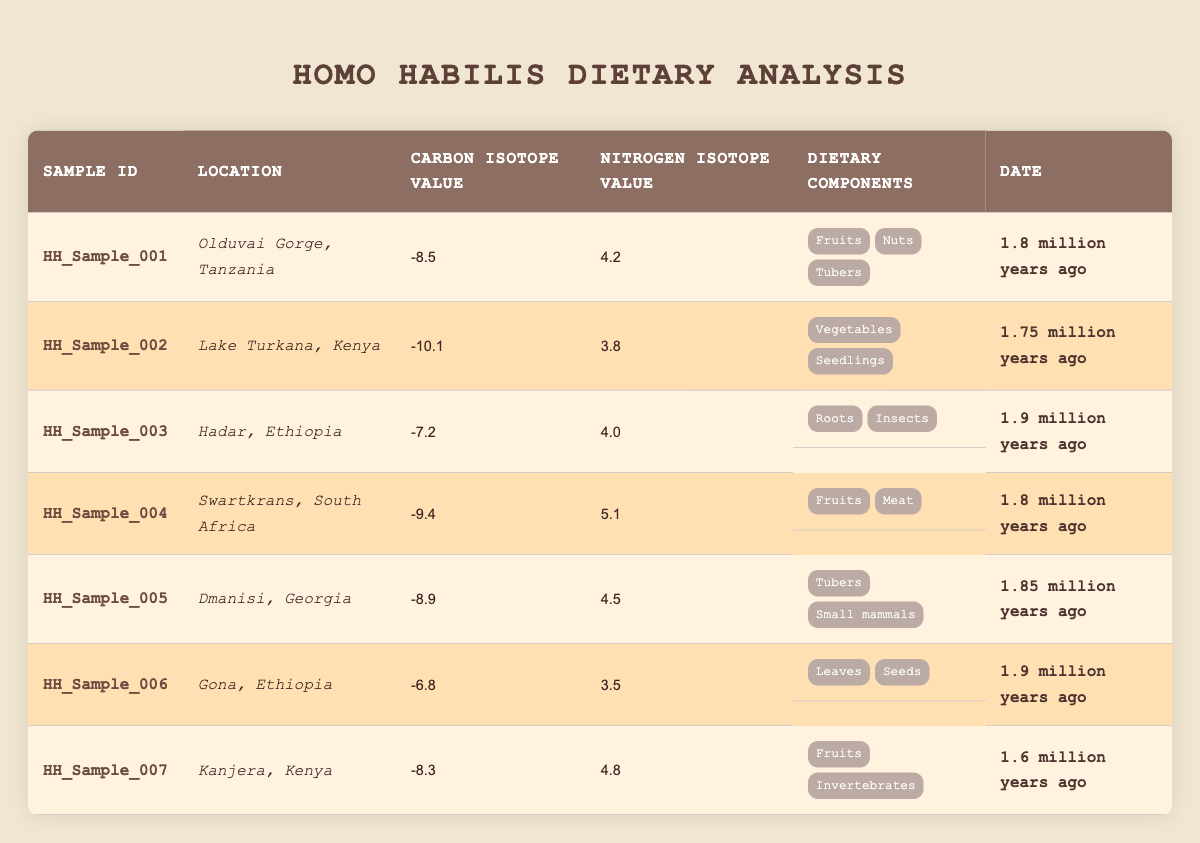What is the Carbon Isotope Value for the sample from Olduvai Gorge? The table lists the Carbon Isotope Value for the sample from Olduvai Gorge (Sample ID HH_Sample_001) as -8.5.
Answer: -8.5 Which sample has the highest Nitrogen Isotope Value? Upon examining the Nitrogen Isotope Values, Swartkrans (Sample ID HH_Sample_004) has the highest value of 5.1.
Answer: HH_Sample_004 How many dietary components are listed for the sample from Hadar? The table shows that the dietary components for the Hadar sample (Sample ID HH_Sample_003) include Roots and Insects, which totals to 2 components.
Answer: 2 Is there a sample that includes both fruits and meat in its dietary components? Yes, the Swartkrans sample (Sample ID HH_Sample_004) includes both fruits and meat in its dietary components.
Answer: Yes What is the difference between the highest and lowest Carbon Isotope Values? Checking the values, the highest Carbon Isotope Value is -6.8 (Sample HH_Sample_006) and the lowest is -10.1 (Sample HH_Sample_002). The difference is calculated as -6.8 - (-10.1) = 3.3.
Answer: 3.3 Which site has dietary components that include nuts? The site that includes dietary components of nuts is Olduvai Gorge (Sample ID HH_Sample_001).
Answer: Olduvai Gorge What is the average of the Nitrogen Isotope Values from all samples? The Nitrogen Isotope Values are 4.2, 3.8, 4.0, 5.1, 4.5, 3.5, and 4.8. Summing these values gives 30.9, and there are 7 samples. The average is calculated as 30.9 / 7 = 4.4142857, approximately 4.41.
Answer: 4.41 Which location had the sample dated at 1.9 million years ago with the highest Carbon Isotope Value? The samples dated at 1.9 million years ago are from Hadar (Carbon Isotope -7.2) and Gona (Carbon Isotope -6.8). Gona has the highest value at -6.8.
Answer: Gona Is it true that the maximum average dietary diversity is represented in the sample from Lake Turkana? Analyzing the dietary components, Lake Turkana has 2 components (Vegetables and Seedlings), while the sample from Swartkrans with 2 components (Fruits and Meat) yields slightly higher diversity. Thus, Lake Turkana does not represent maximum diversity.
Answer: No Which samples were collected from Kenya? The samples from Kenya are HH_Sample_002 (Lake Turkana) and HH_Sample_007 (Kanjera).
Answer: HH_Sample_002 and HH_Sample_007 What is the overall trend in Carbon Isotope Values across the samples as they become more recent? Examining the Carbon Isotope Values shows they range from -10.1 (oldest) to -6.8 (most recent). This trend indicates an overall increase in Carbon Isotope Values over time.
Answer: Increase 